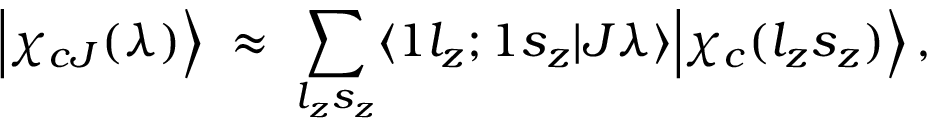Convert formula to latex. <formula><loc_0><loc_0><loc_500><loc_500>\Big | \chi _ { c J } ( \lambda ) \Big \rangle \, \approx \, \sum _ { l _ { z } s _ { z } } \langle 1 l _ { z } ; 1 s _ { z } | J \lambda \rangle \Big | \chi _ { c } ( l _ { z } s _ { z } ) \Big \rangle \, ,</formula> 